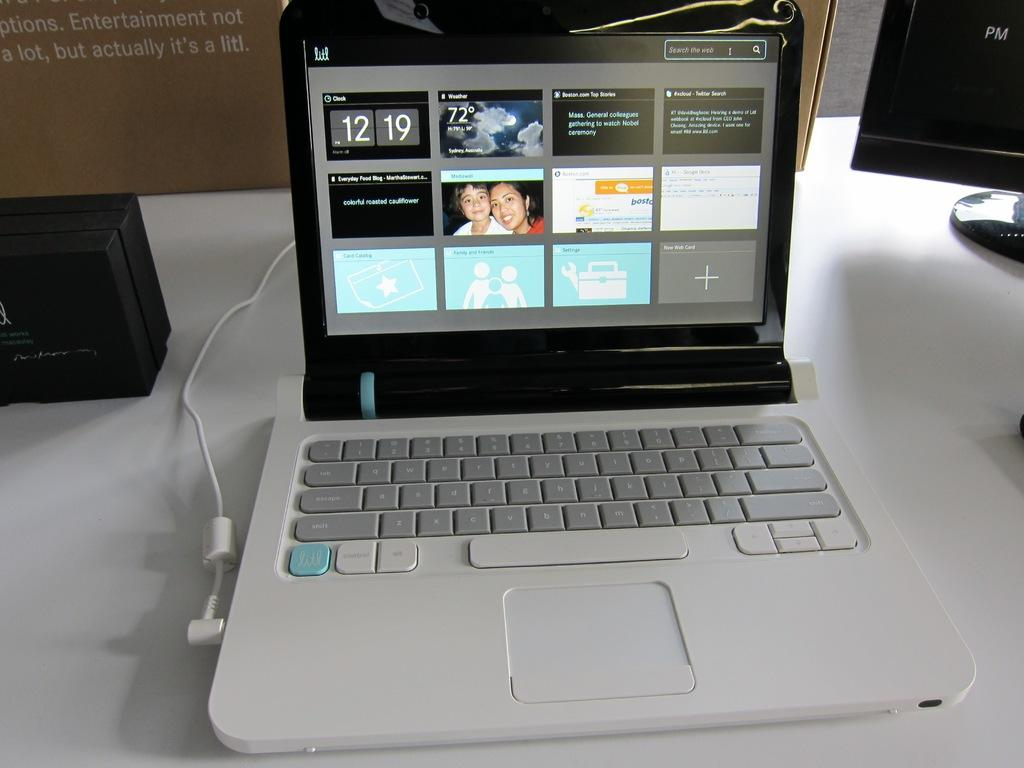What electronic devices are placed on the table in the image? There are laptops placed on a table in the image. What else can be seen on the table besides the laptops? There are boxes visible in the image. What type of rock is being used as a faucet in the image? There is no rock or faucet present in the image; it only features laptops and boxes on a table. 